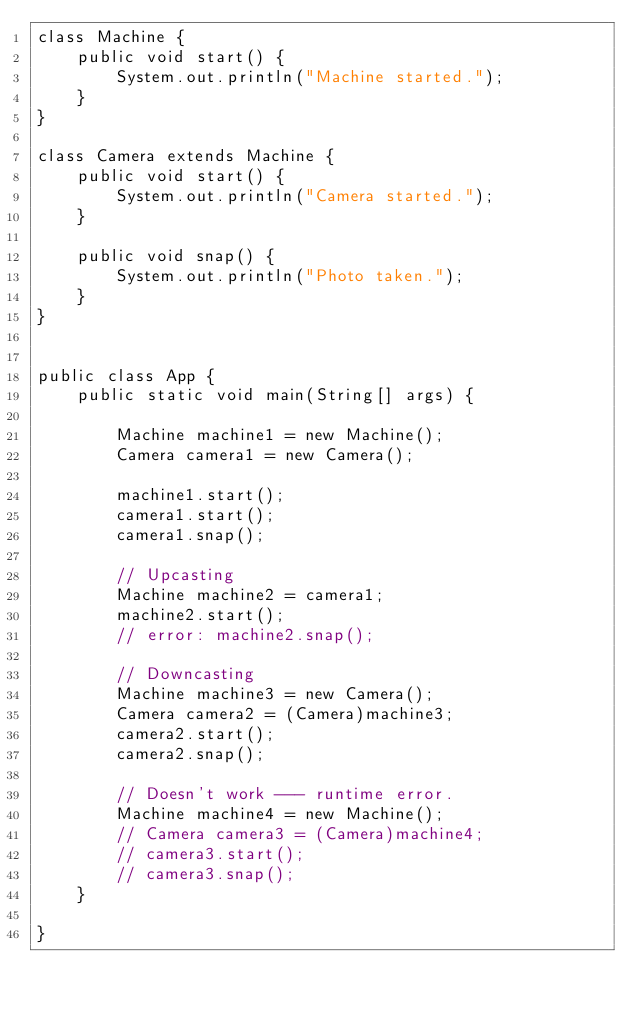<code> <loc_0><loc_0><loc_500><loc_500><_Java_>class Machine {
    public void start() {
        System.out.println("Machine started.");
    }
}
 
class Camera extends Machine {
    public void start() {
        System.out.println("Camera started.");
    }
     
    public void snap() {
        System.out.println("Photo taken.");
    }
}
 
 
public class App {
    public static void main(String[] args) {
 
        Machine machine1 = new Machine();
        Camera camera1 = new Camera();
         
        machine1.start();
        camera1.start();
        camera1.snap();
         
        // Upcasting 
        Machine machine2 = camera1;
        machine2.start();
        // error: machine2.snap();
 
        // Downcasting
        Machine machine3 = new Camera();
        Camera camera2 = (Camera)machine3;
        camera2.start();
        camera2.snap();
         
        // Doesn't work --- runtime error.
        Machine machine4 = new Machine();
        // Camera camera3 = (Camera)machine4;
        // camera3.start();
        // camera3.snap();
    }
 
}</code> 